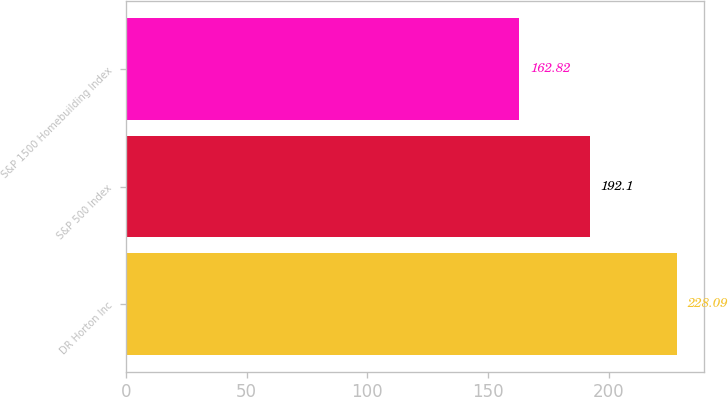<chart> <loc_0><loc_0><loc_500><loc_500><bar_chart><fcel>DR Horton Inc<fcel>S&P 500 Index<fcel>S&P 1500 Homebuilding Index<nl><fcel>228.09<fcel>192.1<fcel>162.82<nl></chart> 